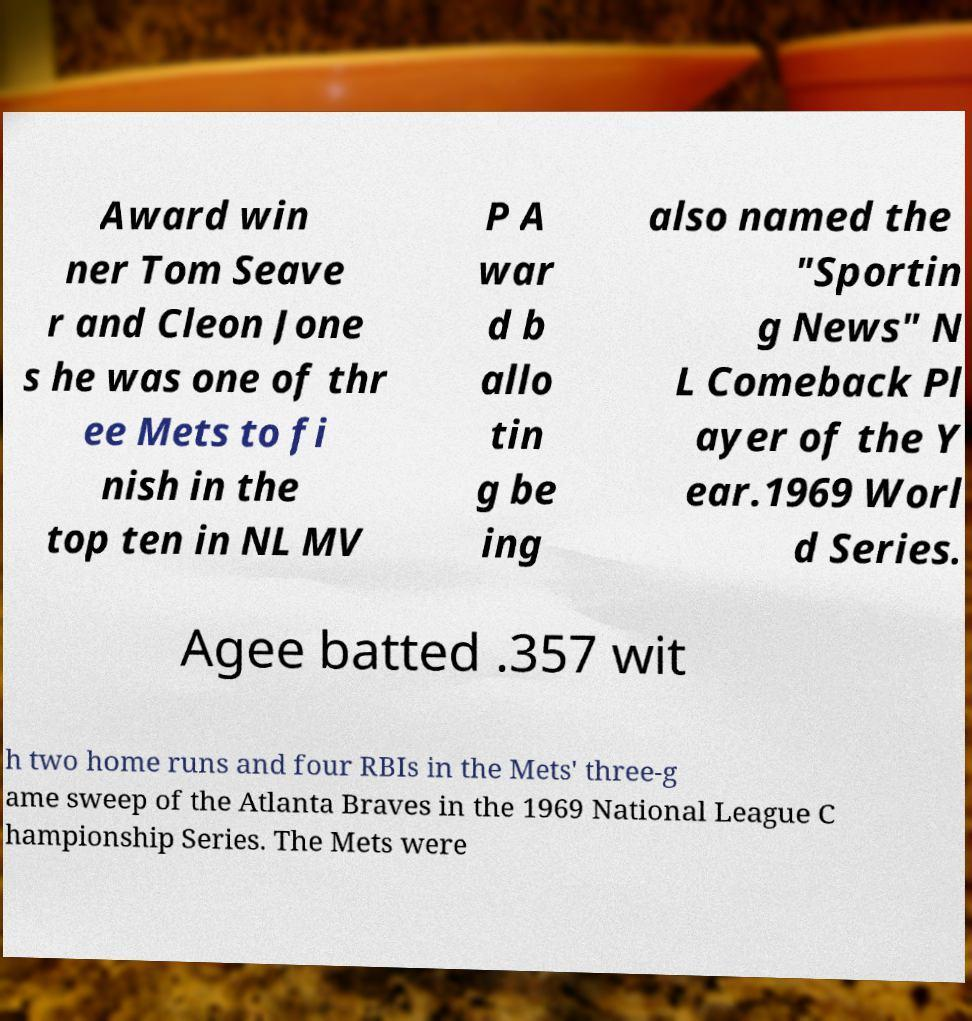Could you assist in decoding the text presented in this image and type it out clearly? Award win ner Tom Seave r and Cleon Jone s he was one of thr ee Mets to fi nish in the top ten in NL MV P A war d b allo tin g be ing also named the "Sportin g News" N L Comeback Pl ayer of the Y ear.1969 Worl d Series. Agee batted .357 wit h two home runs and four RBIs in the Mets' three-g ame sweep of the Atlanta Braves in the 1969 National League C hampionship Series. The Mets were 